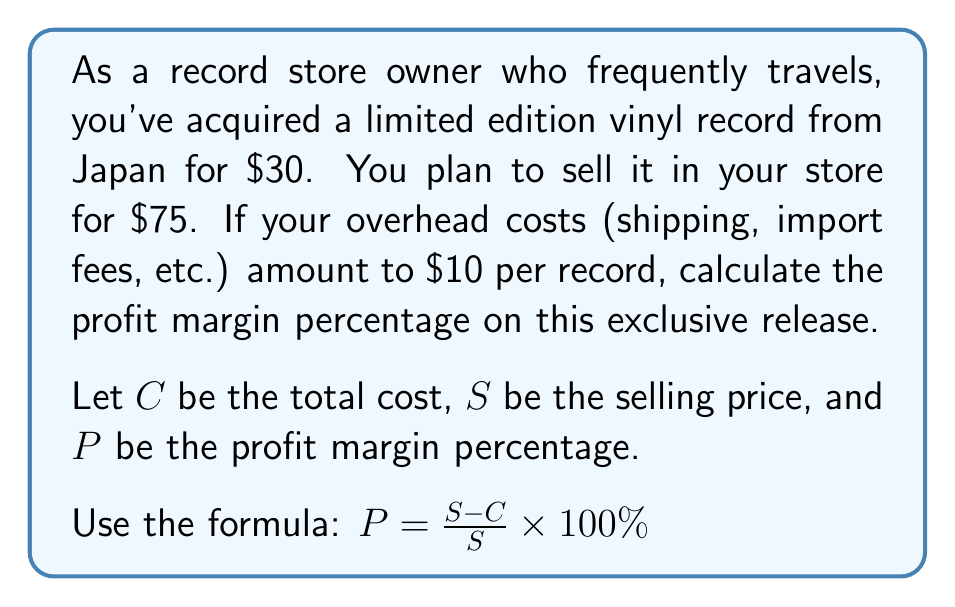Can you answer this question? To solve this problem, we need to follow these steps:

1. Calculate the total cost ($C$):
   $C = \text{Purchase price} + \text{Overhead costs}$
   $C = $30 + $10 = $40$

2. Identify the selling price ($S$):
   $S = $75$

3. Apply the profit margin percentage formula:
   $P = \frac{S - C}{S} \times 100\%$

4. Substitute the values:
   $P = \frac{$75 - $40}{$75} \times 100\%$

5. Simplify:
   $P = \frac{$35}{$75} \times 100\%$

6. Perform the division:
   $P = 0.4666... \times 100\%$

7. Convert to percentage:
   $P \approx 46.67\%$

Therefore, the profit margin percentage on this limited edition vinyl record is approximately 46.67%.
Answer: $46.67\%$ 